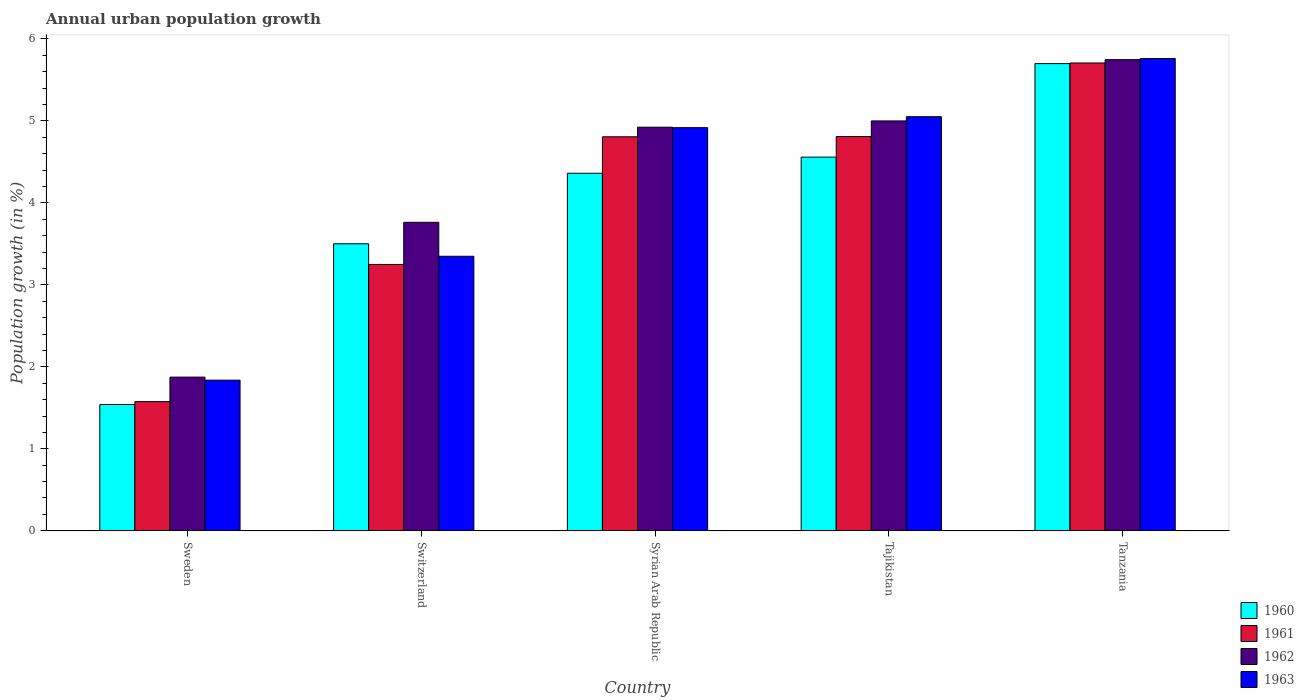Are the number of bars per tick equal to the number of legend labels?
Your answer should be very brief. Yes. How many bars are there on the 1st tick from the left?
Your answer should be compact. 4. How many bars are there on the 2nd tick from the right?
Offer a very short reply. 4. What is the label of the 1st group of bars from the left?
Your response must be concise. Sweden. What is the percentage of urban population growth in 1961 in Tajikistan?
Make the answer very short. 4.81. Across all countries, what is the maximum percentage of urban population growth in 1963?
Provide a short and direct response. 5.76. Across all countries, what is the minimum percentage of urban population growth in 1960?
Give a very brief answer. 1.54. In which country was the percentage of urban population growth in 1961 maximum?
Give a very brief answer. Tanzania. What is the total percentage of urban population growth in 1963 in the graph?
Ensure brevity in your answer.  20.91. What is the difference between the percentage of urban population growth in 1963 in Switzerland and that in Tajikistan?
Make the answer very short. -1.7. What is the difference between the percentage of urban population growth in 1962 in Switzerland and the percentage of urban population growth in 1960 in Syrian Arab Republic?
Keep it short and to the point. -0.6. What is the average percentage of urban population growth in 1962 per country?
Your response must be concise. 4.26. What is the difference between the percentage of urban population growth of/in 1961 and percentage of urban population growth of/in 1960 in Sweden?
Make the answer very short. 0.04. What is the ratio of the percentage of urban population growth in 1962 in Sweden to that in Switzerland?
Give a very brief answer. 0.5. Is the percentage of urban population growth in 1962 in Switzerland less than that in Tanzania?
Make the answer very short. Yes. Is the difference between the percentage of urban population growth in 1961 in Sweden and Tanzania greater than the difference between the percentage of urban population growth in 1960 in Sweden and Tanzania?
Your answer should be compact. Yes. What is the difference between the highest and the second highest percentage of urban population growth in 1960?
Give a very brief answer. -0.2. What is the difference between the highest and the lowest percentage of urban population growth in 1962?
Provide a short and direct response. 3.87. In how many countries, is the percentage of urban population growth in 1962 greater than the average percentage of urban population growth in 1962 taken over all countries?
Ensure brevity in your answer.  3. Is the sum of the percentage of urban population growth in 1961 in Syrian Arab Republic and Tajikistan greater than the maximum percentage of urban population growth in 1962 across all countries?
Your answer should be compact. Yes. What does the 1st bar from the left in Syrian Arab Republic represents?
Provide a short and direct response. 1960. Is it the case that in every country, the sum of the percentage of urban population growth in 1962 and percentage of urban population growth in 1961 is greater than the percentage of urban population growth in 1960?
Ensure brevity in your answer.  Yes. Are all the bars in the graph horizontal?
Offer a terse response. No. Does the graph contain any zero values?
Ensure brevity in your answer.  No. Does the graph contain grids?
Make the answer very short. No. Where does the legend appear in the graph?
Offer a very short reply. Bottom right. What is the title of the graph?
Offer a very short reply. Annual urban population growth. What is the label or title of the X-axis?
Provide a succinct answer. Country. What is the label or title of the Y-axis?
Give a very brief answer. Population growth (in %). What is the Population growth (in %) of 1960 in Sweden?
Your answer should be compact. 1.54. What is the Population growth (in %) in 1961 in Sweden?
Give a very brief answer. 1.58. What is the Population growth (in %) of 1962 in Sweden?
Make the answer very short. 1.87. What is the Population growth (in %) in 1963 in Sweden?
Keep it short and to the point. 1.84. What is the Population growth (in %) in 1960 in Switzerland?
Provide a short and direct response. 3.5. What is the Population growth (in %) of 1961 in Switzerland?
Offer a terse response. 3.25. What is the Population growth (in %) in 1962 in Switzerland?
Your answer should be very brief. 3.76. What is the Population growth (in %) in 1963 in Switzerland?
Provide a succinct answer. 3.35. What is the Population growth (in %) of 1960 in Syrian Arab Republic?
Offer a very short reply. 4.36. What is the Population growth (in %) in 1961 in Syrian Arab Republic?
Give a very brief answer. 4.81. What is the Population growth (in %) in 1962 in Syrian Arab Republic?
Provide a short and direct response. 4.92. What is the Population growth (in %) in 1963 in Syrian Arab Republic?
Your response must be concise. 4.92. What is the Population growth (in %) in 1960 in Tajikistan?
Your response must be concise. 4.56. What is the Population growth (in %) in 1961 in Tajikistan?
Ensure brevity in your answer.  4.81. What is the Population growth (in %) of 1962 in Tajikistan?
Provide a short and direct response. 5. What is the Population growth (in %) of 1963 in Tajikistan?
Make the answer very short. 5.05. What is the Population growth (in %) of 1960 in Tanzania?
Provide a short and direct response. 5.7. What is the Population growth (in %) in 1961 in Tanzania?
Keep it short and to the point. 5.71. What is the Population growth (in %) in 1962 in Tanzania?
Keep it short and to the point. 5.75. What is the Population growth (in %) of 1963 in Tanzania?
Your answer should be very brief. 5.76. Across all countries, what is the maximum Population growth (in %) in 1960?
Your answer should be compact. 5.7. Across all countries, what is the maximum Population growth (in %) in 1961?
Offer a terse response. 5.71. Across all countries, what is the maximum Population growth (in %) of 1962?
Ensure brevity in your answer.  5.75. Across all countries, what is the maximum Population growth (in %) in 1963?
Offer a very short reply. 5.76. Across all countries, what is the minimum Population growth (in %) of 1960?
Your answer should be very brief. 1.54. Across all countries, what is the minimum Population growth (in %) of 1961?
Provide a succinct answer. 1.58. Across all countries, what is the minimum Population growth (in %) of 1962?
Your answer should be compact. 1.87. Across all countries, what is the minimum Population growth (in %) in 1963?
Keep it short and to the point. 1.84. What is the total Population growth (in %) of 1960 in the graph?
Your answer should be compact. 19.66. What is the total Population growth (in %) of 1961 in the graph?
Provide a succinct answer. 20.14. What is the total Population growth (in %) of 1962 in the graph?
Make the answer very short. 21.3. What is the total Population growth (in %) in 1963 in the graph?
Your response must be concise. 20.91. What is the difference between the Population growth (in %) of 1960 in Sweden and that in Switzerland?
Ensure brevity in your answer.  -1.96. What is the difference between the Population growth (in %) of 1961 in Sweden and that in Switzerland?
Make the answer very short. -1.67. What is the difference between the Population growth (in %) of 1962 in Sweden and that in Switzerland?
Your response must be concise. -1.89. What is the difference between the Population growth (in %) of 1963 in Sweden and that in Switzerland?
Offer a terse response. -1.51. What is the difference between the Population growth (in %) in 1960 in Sweden and that in Syrian Arab Republic?
Make the answer very short. -2.82. What is the difference between the Population growth (in %) of 1961 in Sweden and that in Syrian Arab Republic?
Provide a short and direct response. -3.23. What is the difference between the Population growth (in %) in 1962 in Sweden and that in Syrian Arab Republic?
Give a very brief answer. -3.05. What is the difference between the Population growth (in %) in 1963 in Sweden and that in Syrian Arab Republic?
Offer a very short reply. -3.08. What is the difference between the Population growth (in %) of 1960 in Sweden and that in Tajikistan?
Ensure brevity in your answer.  -3.02. What is the difference between the Population growth (in %) of 1961 in Sweden and that in Tajikistan?
Make the answer very short. -3.23. What is the difference between the Population growth (in %) in 1962 in Sweden and that in Tajikistan?
Ensure brevity in your answer.  -3.12. What is the difference between the Population growth (in %) of 1963 in Sweden and that in Tajikistan?
Keep it short and to the point. -3.21. What is the difference between the Population growth (in %) of 1960 in Sweden and that in Tanzania?
Make the answer very short. -4.16. What is the difference between the Population growth (in %) in 1961 in Sweden and that in Tanzania?
Make the answer very short. -4.13. What is the difference between the Population growth (in %) of 1962 in Sweden and that in Tanzania?
Your answer should be compact. -3.87. What is the difference between the Population growth (in %) of 1963 in Sweden and that in Tanzania?
Provide a succinct answer. -3.92. What is the difference between the Population growth (in %) of 1960 in Switzerland and that in Syrian Arab Republic?
Provide a succinct answer. -0.86. What is the difference between the Population growth (in %) in 1961 in Switzerland and that in Syrian Arab Republic?
Give a very brief answer. -1.56. What is the difference between the Population growth (in %) in 1962 in Switzerland and that in Syrian Arab Republic?
Provide a succinct answer. -1.16. What is the difference between the Population growth (in %) in 1963 in Switzerland and that in Syrian Arab Republic?
Keep it short and to the point. -1.57. What is the difference between the Population growth (in %) of 1960 in Switzerland and that in Tajikistan?
Ensure brevity in your answer.  -1.06. What is the difference between the Population growth (in %) of 1961 in Switzerland and that in Tajikistan?
Give a very brief answer. -1.56. What is the difference between the Population growth (in %) in 1962 in Switzerland and that in Tajikistan?
Ensure brevity in your answer.  -1.24. What is the difference between the Population growth (in %) of 1963 in Switzerland and that in Tajikistan?
Your answer should be very brief. -1.7. What is the difference between the Population growth (in %) in 1960 in Switzerland and that in Tanzania?
Your answer should be compact. -2.2. What is the difference between the Population growth (in %) of 1961 in Switzerland and that in Tanzania?
Keep it short and to the point. -2.46. What is the difference between the Population growth (in %) of 1962 in Switzerland and that in Tanzania?
Offer a very short reply. -1.98. What is the difference between the Population growth (in %) in 1963 in Switzerland and that in Tanzania?
Offer a terse response. -2.41. What is the difference between the Population growth (in %) in 1960 in Syrian Arab Republic and that in Tajikistan?
Offer a terse response. -0.2. What is the difference between the Population growth (in %) of 1961 in Syrian Arab Republic and that in Tajikistan?
Offer a very short reply. -0. What is the difference between the Population growth (in %) in 1962 in Syrian Arab Republic and that in Tajikistan?
Ensure brevity in your answer.  -0.08. What is the difference between the Population growth (in %) of 1963 in Syrian Arab Republic and that in Tajikistan?
Give a very brief answer. -0.13. What is the difference between the Population growth (in %) in 1960 in Syrian Arab Republic and that in Tanzania?
Offer a terse response. -1.34. What is the difference between the Population growth (in %) in 1961 in Syrian Arab Republic and that in Tanzania?
Offer a terse response. -0.9. What is the difference between the Population growth (in %) in 1962 in Syrian Arab Republic and that in Tanzania?
Your response must be concise. -0.82. What is the difference between the Population growth (in %) of 1963 in Syrian Arab Republic and that in Tanzania?
Provide a succinct answer. -0.84. What is the difference between the Population growth (in %) of 1960 in Tajikistan and that in Tanzania?
Your response must be concise. -1.14. What is the difference between the Population growth (in %) in 1961 in Tajikistan and that in Tanzania?
Give a very brief answer. -0.9. What is the difference between the Population growth (in %) in 1962 in Tajikistan and that in Tanzania?
Offer a terse response. -0.75. What is the difference between the Population growth (in %) in 1963 in Tajikistan and that in Tanzania?
Offer a very short reply. -0.71. What is the difference between the Population growth (in %) of 1960 in Sweden and the Population growth (in %) of 1961 in Switzerland?
Keep it short and to the point. -1.71. What is the difference between the Population growth (in %) of 1960 in Sweden and the Population growth (in %) of 1962 in Switzerland?
Offer a terse response. -2.22. What is the difference between the Population growth (in %) of 1960 in Sweden and the Population growth (in %) of 1963 in Switzerland?
Provide a succinct answer. -1.81. What is the difference between the Population growth (in %) of 1961 in Sweden and the Population growth (in %) of 1962 in Switzerland?
Your answer should be very brief. -2.19. What is the difference between the Population growth (in %) of 1961 in Sweden and the Population growth (in %) of 1963 in Switzerland?
Your response must be concise. -1.77. What is the difference between the Population growth (in %) in 1962 in Sweden and the Population growth (in %) in 1963 in Switzerland?
Your response must be concise. -1.47. What is the difference between the Population growth (in %) of 1960 in Sweden and the Population growth (in %) of 1961 in Syrian Arab Republic?
Provide a short and direct response. -3.27. What is the difference between the Population growth (in %) of 1960 in Sweden and the Population growth (in %) of 1962 in Syrian Arab Republic?
Make the answer very short. -3.38. What is the difference between the Population growth (in %) in 1960 in Sweden and the Population growth (in %) in 1963 in Syrian Arab Republic?
Offer a terse response. -3.38. What is the difference between the Population growth (in %) in 1961 in Sweden and the Population growth (in %) in 1962 in Syrian Arab Republic?
Ensure brevity in your answer.  -3.35. What is the difference between the Population growth (in %) of 1961 in Sweden and the Population growth (in %) of 1963 in Syrian Arab Republic?
Make the answer very short. -3.34. What is the difference between the Population growth (in %) in 1962 in Sweden and the Population growth (in %) in 1963 in Syrian Arab Republic?
Your answer should be compact. -3.04. What is the difference between the Population growth (in %) of 1960 in Sweden and the Population growth (in %) of 1961 in Tajikistan?
Make the answer very short. -3.27. What is the difference between the Population growth (in %) in 1960 in Sweden and the Population growth (in %) in 1962 in Tajikistan?
Offer a terse response. -3.46. What is the difference between the Population growth (in %) in 1960 in Sweden and the Population growth (in %) in 1963 in Tajikistan?
Provide a short and direct response. -3.51. What is the difference between the Population growth (in %) of 1961 in Sweden and the Population growth (in %) of 1962 in Tajikistan?
Make the answer very short. -3.42. What is the difference between the Population growth (in %) in 1961 in Sweden and the Population growth (in %) in 1963 in Tajikistan?
Provide a succinct answer. -3.47. What is the difference between the Population growth (in %) of 1962 in Sweden and the Population growth (in %) of 1963 in Tajikistan?
Offer a terse response. -3.18. What is the difference between the Population growth (in %) in 1960 in Sweden and the Population growth (in %) in 1961 in Tanzania?
Provide a succinct answer. -4.17. What is the difference between the Population growth (in %) in 1960 in Sweden and the Population growth (in %) in 1962 in Tanzania?
Offer a very short reply. -4.21. What is the difference between the Population growth (in %) of 1960 in Sweden and the Population growth (in %) of 1963 in Tanzania?
Offer a terse response. -4.22. What is the difference between the Population growth (in %) of 1961 in Sweden and the Population growth (in %) of 1962 in Tanzania?
Ensure brevity in your answer.  -4.17. What is the difference between the Population growth (in %) in 1961 in Sweden and the Population growth (in %) in 1963 in Tanzania?
Keep it short and to the point. -4.18. What is the difference between the Population growth (in %) in 1962 in Sweden and the Population growth (in %) in 1963 in Tanzania?
Provide a succinct answer. -3.89. What is the difference between the Population growth (in %) of 1960 in Switzerland and the Population growth (in %) of 1961 in Syrian Arab Republic?
Keep it short and to the point. -1.31. What is the difference between the Population growth (in %) in 1960 in Switzerland and the Population growth (in %) in 1962 in Syrian Arab Republic?
Your answer should be compact. -1.42. What is the difference between the Population growth (in %) in 1960 in Switzerland and the Population growth (in %) in 1963 in Syrian Arab Republic?
Offer a very short reply. -1.42. What is the difference between the Population growth (in %) of 1961 in Switzerland and the Population growth (in %) of 1962 in Syrian Arab Republic?
Keep it short and to the point. -1.67. What is the difference between the Population growth (in %) of 1961 in Switzerland and the Population growth (in %) of 1963 in Syrian Arab Republic?
Offer a very short reply. -1.67. What is the difference between the Population growth (in %) in 1962 in Switzerland and the Population growth (in %) in 1963 in Syrian Arab Republic?
Provide a succinct answer. -1.15. What is the difference between the Population growth (in %) of 1960 in Switzerland and the Population growth (in %) of 1961 in Tajikistan?
Offer a very short reply. -1.31. What is the difference between the Population growth (in %) in 1960 in Switzerland and the Population growth (in %) in 1962 in Tajikistan?
Provide a succinct answer. -1.5. What is the difference between the Population growth (in %) in 1960 in Switzerland and the Population growth (in %) in 1963 in Tajikistan?
Offer a very short reply. -1.55. What is the difference between the Population growth (in %) in 1961 in Switzerland and the Population growth (in %) in 1962 in Tajikistan?
Offer a terse response. -1.75. What is the difference between the Population growth (in %) of 1961 in Switzerland and the Population growth (in %) of 1963 in Tajikistan?
Your answer should be very brief. -1.8. What is the difference between the Population growth (in %) of 1962 in Switzerland and the Population growth (in %) of 1963 in Tajikistan?
Offer a terse response. -1.29. What is the difference between the Population growth (in %) of 1960 in Switzerland and the Population growth (in %) of 1961 in Tanzania?
Offer a very short reply. -2.21. What is the difference between the Population growth (in %) in 1960 in Switzerland and the Population growth (in %) in 1962 in Tanzania?
Ensure brevity in your answer.  -2.25. What is the difference between the Population growth (in %) of 1960 in Switzerland and the Population growth (in %) of 1963 in Tanzania?
Offer a terse response. -2.26. What is the difference between the Population growth (in %) of 1961 in Switzerland and the Population growth (in %) of 1962 in Tanzania?
Give a very brief answer. -2.5. What is the difference between the Population growth (in %) of 1961 in Switzerland and the Population growth (in %) of 1963 in Tanzania?
Offer a terse response. -2.51. What is the difference between the Population growth (in %) in 1962 in Switzerland and the Population growth (in %) in 1963 in Tanzania?
Provide a short and direct response. -2. What is the difference between the Population growth (in %) of 1960 in Syrian Arab Republic and the Population growth (in %) of 1961 in Tajikistan?
Your answer should be compact. -0.45. What is the difference between the Population growth (in %) in 1960 in Syrian Arab Republic and the Population growth (in %) in 1962 in Tajikistan?
Your response must be concise. -0.64. What is the difference between the Population growth (in %) in 1960 in Syrian Arab Republic and the Population growth (in %) in 1963 in Tajikistan?
Make the answer very short. -0.69. What is the difference between the Population growth (in %) in 1961 in Syrian Arab Republic and the Population growth (in %) in 1962 in Tajikistan?
Your answer should be compact. -0.19. What is the difference between the Population growth (in %) of 1961 in Syrian Arab Republic and the Population growth (in %) of 1963 in Tajikistan?
Give a very brief answer. -0.24. What is the difference between the Population growth (in %) of 1962 in Syrian Arab Republic and the Population growth (in %) of 1963 in Tajikistan?
Ensure brevity in your answer.  -0.13. What is the difference between the Population growth (in %) in 1960 in Syrian Arab Republic and the Population growth (in %) in 1961 in Tanzania?
Offer a very short reply. -1.34. What is the difference between the Population growth (in %) in 1960 in Syrian Arab Republic and the Population growth (in %) in 1962 in Tanzania?
Keep it short and to the point. -1.39. What is the difference between the Population growth (in %) in 1960 in Syrian Arab Republic and the Population growth (in %) in 1963 in Tanzania?
Make the answer very short. -1.4. What is the difference between the Population growth (in %) of 1961 in Syrian Arab Republic and the Population growth (in %) of 1962 in Tanzania?
Give a very brief answer. -0.94. What is the difference between the Population growth (in %) in 1961 in Syrian Arab Republic and the Population growth (in %) in 1963 in Tanzania?
Make the answer very short. -0.95. What is the difference between the Population growth (in %) in 1962 in Syrian Arab Republic and the Population growth (in %) in 1963 in Tanzania?
Offer a terse response. -0.84. What is the difference between the Population growth (in %) of 1960 in Tajikistan and the Population growth (in %) of 1961 in Tanzania?
Ensure brevity in your answer.  -1.15. What is the difference between the Population growth (in %) in 1960 in Tajikistan and the Population growth (in %) in 1962 in Tanzania?
Keep it short and to the point. -1.19. What is the difference between the Population growth (in %) of 1960 in Tajikistan and the Population growth (in %) of 1963 in Tanzania?
Ensure brevity in your answer.  -1.2. What is the difference between the Population growth (in %) in 1961 in Tajikistan and the Population growth (in %) in 1962 in Tanzania?
Your answer should be very brief. -0.94. What is the difference between the Population growth (in %) in 1961 in Tajikistan and the Population growth (in %) in 1963 in Tanzania?
Your answer should be compact. -0.95. What is the difference between the Population growth (in %) in 1962 in Tajikistan and the Population growth (in %) in 1963 in Tanzania?
Your answer should be compact. -0.76. What is the average Population growth (in %) of 1960 per country?
Make the answer very short. 3.93. What is the average Population growth (in %) of 1961 per country?
Offer a terse response. 4.03. What is the average Population growth (in %) of 1962 per country?
Your answer should be very brief. 4.26. What is the average Population growth (in %) in 1963 per country?
Provide a short and direct response. 4.18. What is the difference between the Population growth (in %) in 1960 and Population growth (in %) in 1961 in Sweden?
Your answer should be very brief. -0.04. What is the difference between the Population growth (in %) in 1960 and Population growth (in %) in 1962 in Sweden?
Your answer should be compact. -0.33. What is the difference between the Population growth (in %) in 1960 and Population growth (in %) in 1963 in Sweden?
Your response must be concise. -0.3. What is the difference between the Population growth (in %) of 1961 and Population growth (in %) of 1962 in Sweden?
Provide a succinct answer. -0.3. What is the difference between the Population growth (in %) in 1961 and Population growth (in %) in 1963 in Sweden?
Make the answer very short. -0.26. What is the difference between the Population growth (in %) of 1962 and Population growth (in %) of 1963 in Sweden?
Your response must be concise. 0.04. What is the difference between the Population growth (in %) in 1960 and Population growth (in %) in 1961 in Switzerland?
Offer a very short reply. 0.25. What is the difference between the Population growth (in %) of 1960 and Population growth (in %) of 1962 in Switzerland?
Keep it short and to the point. -0.26. What is the difference between the Population growth (in %) of 1960 and Population growth (in %) of 1963 in Switzerland?
Your response must be concise. 0.15. What is the difference between the Population growth (in %) in 1961 and Population growth (in %) in 1962 in Switzerland?
Ensure brevity in your answer.  -0.51. What is the difference between the Population growth (in %) of 1961 and Population growth (in %) of 1963 in Switzerland?
Your answer should be very brief. -0.1. What is the difference between the Population growth (in %) of 1962 and Population growth (in %) of 1963 in Switzerland?
Ensure brevity in your answer.  0.41. What is the difference between the Population growth (in %) of 1960 and Population growth (in %) of 1961 in Syrian Arab Republic?
Provide a succinct answer. -0.44. What is the difference between the Population growth (in %) in 1960 and Population growth (in %) in 1962 in Syrian Arab Republic?
Offer a very short reply. -0.56. What is the difference between the Population growth (in %) of 1960 and Population growth (in %) of 1963 in Syrian Arab Republic?
Your response must be concise. -0.56. What is the difference between the Population growth (in %) in 1961 and Population growth (in %) in 1962 in Syrian Arab Republic?
Ensure brevity in your answer.  -0.12. What is the difference between the Population growth (in %) in 1961 and Population growth (in %) in 1963 in Syrian Arab Republic?
Give a very brief answer. -0.11. What is the difference between the Population growth (in %) in 1962 and Population growth (in %) in 1963 in Syrian Arab Republic?
Give a very brief answer. 0.01. What is the difference between the Population growth (in %) of 1960 and Population growth (in %) of 1961 in Tajikistan?
Your response must be concise. -0.25. What is the difference between the Population growth (in %) of 1960 and Population growth (in %) of 1962 in Tajikistan?
Provide a succinct answer. -0.44. What is the difference between the Population growth (in %) in 1960 and Population growth (in %) in 1963 in Tajikistan?
Give a very brief answer. -0.49. What is the difference between the Population growth (in %) in 1961 and Population growth (in %) in 1962 in Tajikistan?
Give a very brief answer. -0.19. What is the difference between the Population growth (in %) in 1961 and Population growth (in %) in 1963 in Tajikistan?
Your answer should be compact. -0.24. What is the difference between the Population growth (in %) in 1962 and Population growth (in %) in 1963 in Tajikistan?
Make the answer very short. -0.05. What is the difference between the Population growth (in %) in 1960 and Population growth (in %) in 1961 in Tanzania?
Your answer should be compact. -0.01. What is the difference between the Population growth (in %) in 1960 and Population growth (in %) in 1962 in Tanzania?
Ensure brevity in your answer.  -0.05. What is the difference between the Population growth (in %) of 1960 and Population growth (in %) of 1963 in Tanzania?
Give a very brief answer. -0.06. What is the difference between the Population growth (in %) in 1961 and Population growth (in %) in 1962 in Tanzania?
Give a very brief answer. -0.04. What is the difference between the Population growth (in %) of 1961 and Population growth (in %) of 1963 in Tanzania?
Your response must be concise. -0.05. What is the difference between the Population growth (in %) of 1962 and Population growth (in %) of 1963 in Tanzania?
Your response must be concise. -0.01. What is the ratio of the Population growth (in %) of 1960 in Sweden to that in Switzerland?
Offer a terse response. 0.44. What is the ratio of the Population growth (in %) of 1961 in Sweden to that in Switzerland?
Offer a terse response. 0.48. What is the ratio of the Population growth (in %) of 1962 in Sweden to that in Switzerland?
Provide a short and direct response. 0.5. What is the ratio of the Population growth (in %) of 1963 in Sweden to that in Switzerland?
Make the answer very short. 0.55. What is the ratio of the Population growth (in %) in 1960 in Sweden to that in Syrian Arab Republic?
Give a very brief answer. 0.35. What is the ratio of the Population growth (in %) of 1961 in Sweden to that in Syrian Arab Republic?
Provide a succinct answer. 0.33. What is the ratio of the Population growth (in %) of 1962 in Sweden to that in Syrian Arab Republic?
Offer a terse response. 0.38. What is the ratio of the Population growth (in %) of 1963 in Sweden to that in Syrian Arab Republic?
Keep it short and to the point. 0.37. What is the ratio of the Population growth (in %) in 1960 in Sweden to that in Tajikistan?
Your answer should be compact. 0.34. What is the ratio of the Population growth (in %) in 1961 in Sweden to that in Tajikistan?
Give a very brief answer. 0.33. What is the ratio of the Population growth (in %) of 1963 in Sweden to that in Tajikistan?
Make the answer very short. 0.36. What is the ratio of the Population growth (in %) of 1960 in Sweden to that in Tanzania?
Offer a very short reply. 0.27. What is the ratio of the Population growth (in %) of 1961 in Sweden to that in Tanzania?
Keep it short and to the point. 0.28. What is the ratio of the Population growth (in %) of 1962 in Sweden to that in Tanzania?
Your response must be concise. 0.33. What is the ratio of the Population growth (in %) in 1963 in Sweden to that in Tanzania?
Your answer should be very brief. 0.32. What is the ratio of the Population growth (in %) of 1960 in Switzerland to that in Syrian Arab Republic?
Give a very brief answer. 0.8. What is the ratio of the Population growth (in %) of 1961 in Switzerland to that in Syrian Arab Republic?
Provide a short and direct response. 0.68. What is the ratio of the Population growth (in %) in 1962 in Switzerland to that in Syrian Arab Republic?
Your response must be concise. 0.76. What is the ratio of the Population growth (in %) in 1963 in Switzerland to that in Syrian Arab Republic?
Offer a terse response. 0.68. What is the ratio of the Population growth (in %) of 1960 in Switzerland to that in Tajikistan?
Provide a short and direct response. 0.77. What is the ratio of the Population growth (in %) in 1961 in Switzerland to that in Tajikistan?
Provide a short and direct response. 0.68. What is the ratio of the Population growth (in %) of 1962 in Switzerland to that in Tajikistan?
Offer a terse response. 0.75. What is the ratio of the Population growth (in %) of 1963 in Switzerland to that in Tajikistan?
Your response must be concise. 0.66. What is the ratio of the Population growth (in %) in 1960 in Switzerland to that in Tanzania?
Provide a succinct answer. 0.61. What is the ratio of the Population growth (in %) of 1961 in Switzerland to that in Tanzania?
Offer a very short reply. 0.57. What is the ratio of the Population growth (in %) in 1962 in Switzerland to that in Tanzania?
Give a very brief answer. 0.65. What is the ratio of the Population growth (in %) of 1963 in Switzerland to that in Tanzania?
Your answer should be very brief. 0.58. What is the ratio of the Population growth (in %) in 1960 in Syrian Arab Republic to that in Tajikistan?
Your answer should be very brief. 0.96. What is the ratio of the Population growth (in %) in 1962 in Syrian Arab Republic to that in Tajikistan?
Your response must be concise. 0.98. What is the ratio of the Population growth (in %) in 1963 in Syrian Arab Republic to that in Tajikistan?
Your answer should be very brief. 0.97. What is the ratio of the Population growth (in %) in 1960 in Syrian Arab Republic to that in Tanzania?
Provide a succinct answer. 0.77. What is the ratio of the Population growth (in %) in 1961 in Syrian Arab Republic to that in Tanzania?
Your answer should be very brief. 0.84. What is the ratio of the Population growth (in %) in 1962 in Syrian Arab Republic to that in Tanzania?
Your answer should be very brief. 0.86. What is the ratio of the Population growth (in %) of 1963 in Syrian Arab Republic to that in Tanzania?
Offer a terse response. 0.85. What is the ratio of the Population growth (in %) in 1960 in Tajikistan to that in Tanzania?
Give a very brief answer. 0.8. What is the ratio of the Population growth (in %) in 1961 in Tajikistan to that in Tanzania?
Offer a terse response. 0.84. What is the ratio of the Population growth (in %) in 1962 in Tajikistan to that in Tanzania?
Provide a succinct answer. 0.87. What is the ratio of the Population growth (in %) in 1963 in Tajikistan to that in Tanzania?
Provide a succinct answer. 0.88. What is the difference between the highest and the second highest Population growth (in %) of 1960?
Offer a terse response. 1.14. What is the difference between the highest and the second highest Population growth (in %) of 1961?
Provide a short and direct response. 0.9. What is the difference between the highest and the second highest Population growth (in %) in 1962?
Your answer should be compact. 0.75. What is the difference between the highest and the second highest Population growth (in %) of 1963?
Provide a succinct answer. 0.71. What is the difference between the highest and the lowest Population growth (in %) of 1960?
Your answer should be compact. 4.16. What is the difference between the highest and the lowest Population growth (in %) of 1961?
Provide a short and direct response. 4.13. What is the difference between the highest and the lowest Population growth (in %) of 1962?
Your answer should be compact. 3.87. What is the difference between the highest and the lowest Population growth (in %) of 1963?
Keep it short and to the point. 3.92. 